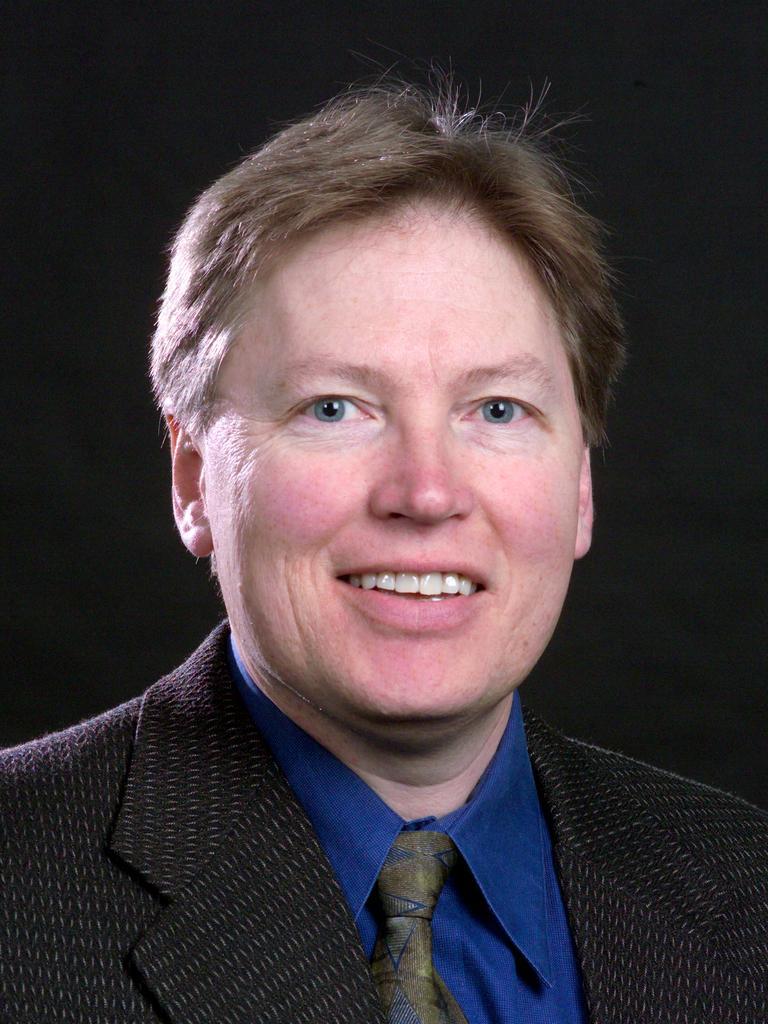In one or two sentences, can you explain what this image depicts? In this image we can see a person with a smile and he is wearing a suit. 